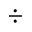<formula> <loc_0><loc_0><loc_500><loc_500>\div</formula> 